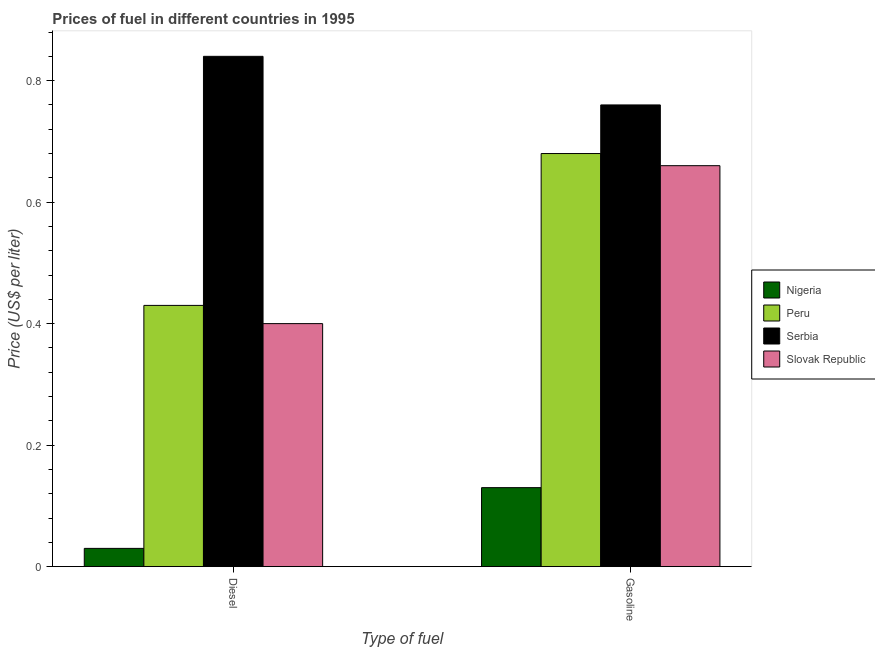How many groups of bars are there?
Your answer should be very brief. 2. Are the number of bars on each tick of the X-axis equal?
Provide a short and direct response. Yes. How many bars are there on the 1st tick from the left?
Your answer should be compact. 4. How many bars are there on the 2nd tick from the right?
Offer a terse response. 4. What is the label of the 1st group of bars from the left?
Offer a terse response. Diesel. What is the gasoline price in Serbia?
Offer a terse response. 0.76. Across all countries, what is the maximum gasoline price?
Your answer should be very brief. 0.76. In which country was the diesel price maximum?
Your answer should be very brief. Serbia. In which country was the diesel price minimum?
Keep it short and to the point. Nigeria. What is the total gasoline price in the graph?
Your answer should be very brief. 2.23. What is the difference between the diesel price in Slovak Republic and that in Serbia?
Your answer should be compact. -0.44. What is the difference between the diesel price in Nigeria and the gasoline price in Slovak Republic?
Offer a terse response. -0.63. What is the average gasoline price per country?
Your answer should be very brief. 0.56. What is the difference between the gasoline price and diesel price in Slovak Republic?
Make the answer very short. 0.26. In how many countries, is the diesel price greater than 0.24000000000000002 US$ per litre?
Make the answer very short. 3. What is the ratio of the gasoline price in Serbia to that in Peru?
Your answer should be compact. 1.12. Is the gasoline price in Slovak Republic less than that in Nigeria?
Your response must be concise. No. What does the 1st bar from the left in Diesel represents?
Give a very brief answer. Nigeria. What does the 1st bar from the right in Gasoline represents?
Provide a succinct answer. Slovak Republic. How many bars are there?
Offer a terse response. 8. Are all the bars in the graph horizontal?
Make the answer very short. No. How many countries are there in the graph?
Your answer should be compact. 4. What is the difference between two consecutive major ticks on the Y-axis?
Ensure brevity in your answer.  0.2. Does the graph contain grids?
Your answer should be very brief. No. Where does the legend appear in the graph?
Ensure brevity in your answer.  Center right. How many legend labels are there?
Your response must be concise. 4. What is the title of the graph?
Offer a terse response. Prices of fuel in different countries in 1995. Does "Dominica" appear as one of the legend labels in the graph?
Offer a terse response. No. What is the label or title of the X-axis?
Provide a short and direct response. Type of fuel. What is the label or title of the Y-axis?
Keep it short and to the point. Price (US$ per liter). What is the Price (US$ per liter) in Peru in Diesel?
Offer a very short reply. 0.43. What is the Price (US$ per liter) of Serbia in Diesel?
Offer a terse response. 0.84. What is the Price (US$ per liter) in Slovak Republic in Diesel?
Make the answer very short. 0.4. What is the Price (US$ per liter) in Nigeria in Gasoline?
Provide a short and direct response. 0.13. What is the Price (US$ per liter) in Peru in Gasoline?
Provide a succinct answer. 0.68. What is the Price (US$ per liter) in Serbia in Gasoline?
Your answer should be compact. 0.76. What is the Price (US$ per liter) in Slovak Republic in Gasoline?
Keep it short and to the point. 0.66. Across all Type of fuel, what is the maximum Price (US$ per liter) in Nigeria?
Your answer should be very brief. 0.13. Across all Type of fuel, what is the maximum Price (US$ per liter) of Peru?
Provide a short and direct response. 0.68. Across all Type of fuel, what is the maximum Price (US$ per liter) of Serbia?
Your answer should be very brief. 0.84. Across all Type of fuel, what is the maximum Price (US$ per liter) in Slovak Republic?
Your response must be concise. 0.66. Across all Type of fuel, what is the minimum Price (US$ per liter) of Nigeria?
Give a very brief answer. 0.03. Across all Type of fuel, what is the minimum Price (US$ per liter) of Peru?
Keep it short and to the point. 0.43. Across all Type of fuel, what is the minimum Price (US$ per liter) in Serbia?
Make the answer very short. 0.76. Across all Type of fuel, what is the minimum Price (US$ per liter) of Slovak Republic?
Offer a very short reply. 0.4. What is the total Price (US$ per liter) in Nigeria in the graph?
Provide a succinct answer. 0.16. What is the total Price (US$ per liter) in Peru in the graph?
Your answer should be very brief. 1.11. What is the total Price (US$ per liter) in Serbia in the graph?
Your response must be concise. 1.6. What is the total Price (US$ per liter) in Slovak Republic in the graph?
Your answer should be very brief. 1.06. What is the difference between the Price (US$ per liter) of Slovak Republic in Diesel and that in Gasoline?
Keep it short and to the point. -0.26. What is the difference between the Price (US$ per liter) in Nigeria in Diesel and the Price (US$ per liter) in Peru in Gasoline?
Keep it short and to the point. -0.65. What is the difference between the Price (US$ per liter) of Nigeria in Diesel and the Price (US$ per liter) of Serbia in Gasoline?
Offer a very short reply. -0.73. What is the difference between the Price (US$ per liter) in Nigeria in Diesel and the Price (US$ per liter) in Slovak Republic in Gasoline?
Provide a short and direct response. -0.63. What is the difference between the Price (US$ per liter) in Peru in Diesel and the Price (US$ per liter) in Serbia in Gasoline?
Make the answer very short. -0.33. What is the difference between the Price (US$ per liter) in Peru in Diesel and the Price (US$ per liter) in Slovak Republic in Gasoline?
Provide a succinct answer. -0.23. What is the difference between the Price (US$ per liter) in Serbia in Diesel and the Price (US$ per liter) in Slovak Republic in Gasoline?
Ensure brevity in your answer.  0.18. What is the average Price (US$ per liter) in Peru per Type of fuel?
Give a very brief answer. 0.56. What is the average Price (US$ per liter) of Slovak Republic per Type of fuel?
Give a very brief answer. 0.53. What is the difference between the Price (US$ per liter) of Nigeria and Price (US$ per liter) of Peru in Diesel?
Provide a succinct answer. -0.4. What is the difference between the Price (US$ per liter) of Nigeria and Price (US$ per liter) of Serbia in Diesel?
Your answer should be compact. -0.81. What is the difference between the Price (US$ per liter) of Nigeria and Price (US$ per liter) of Slovak Republic in Diesel?
Your answer should be very brief. -0.37. What is the difference between the Price (US$ per liter) in Peru and Price (US$ per liter) in Serbia in Diesel?
Make the answer very short. -0.41. What is the difference between the Price (US$ per liter) of Serbia and Price (US$ per liter) of Slovak Republic in Diesel?
Your answer should be very brief. 0.44. What is the difference between the Price (US$ per liter) of Nigeria and Price (US$ per liter) of Peru in Gasoline?
Your answer should be compact. -0.55. What is the difference between the Price (US$ per liter) in Nigeria and Price (US$ per liter) in Serbia in Gasoline?
Ensure brevity in your answer.  -0.63. What is the difference between the Price (US$ per liter) of Nigeria and Price (US$ per liter) of Slovak Republic in Gasoline?
Give a very brief answer. -0.53. What is the difference between the Price (US$ per liter) in Peru and Price (US$ per liter) in Serbia in Gasoline?
Your answer should be compact. -0.08. What is the difference between the Price (US$ per liter) in Peru and Price (US$ per liter) in Slovak Republic in Gasoline?
Ensure brevity in your answer.  0.02. What is the ratio of the Price (US$ per liter) in Nigeria in Diesel to that in Gasoline?
Make the answer very short. 0.23. What is the ratio of the Price (US$ per liter) in Peru in Diesel to that in Gasoline?
Your answer should be compact. 0.63. What is the ratio of the Price (US$ per liter) of Serbia in Diesel to that in Gasoline?
Provide a short and direct response. 1.11. What is the ratio of the Price (US$ per liter) of Slovak Republic in Diesel to that in Gasoline?
Give a very brief answer. 0.61. What is the difference between the highest and the second highest Price (US$ per liter) of Serbia?
Make the answer very short. 0.08. What is the difference between the highest and the second highest Price (US$ per liter) in Slovak Republic?
Make the answer very short. 0.26. What is the difference between the highest and the lowest Price (US$ per liter) of Peru?
Give a very brief answer. 0.25. What is the difference between the highest and the lowest Price (US$ per liter) of Serbia?
Offer a terse response. 0.08. What is the difference between the highest and the lowest Price (US$ per liter) of Slovak Republic?
Provide a short and direct response. 0.26. 